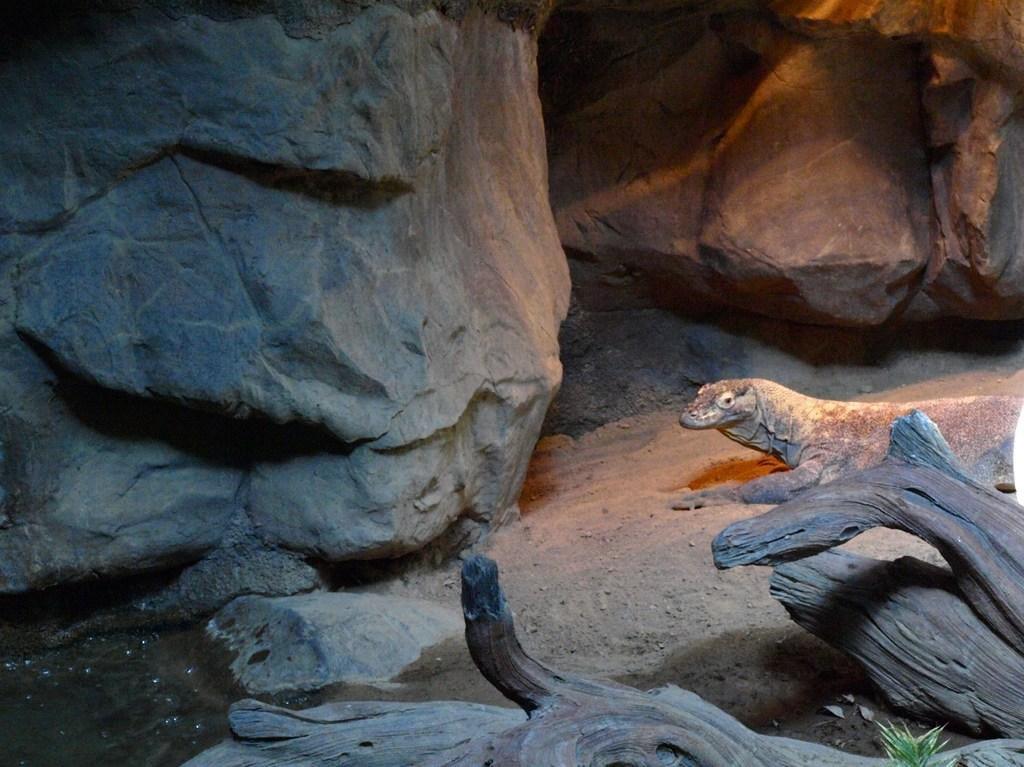What type of animal can be seen in the image? There is an animal in the image, but its specific type cannot be determined from the provided facts. What type of terrain is visible in the image? There is sand, wood, big stones, and water in the image, suggesting a natural environment. What other natural elements can be seen in the image? There are leaves in the image. What type of horn can be seen on the bedroom wall in the image? There is no bedroom or horn present in the image; it features an animal in a natural environment. 